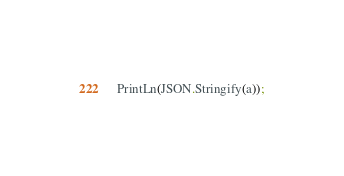<code> <loc_0><loc_0><loc_500><loc_500><_Pascal_>
PrintLn(JSON.Stringify(a));</code> 